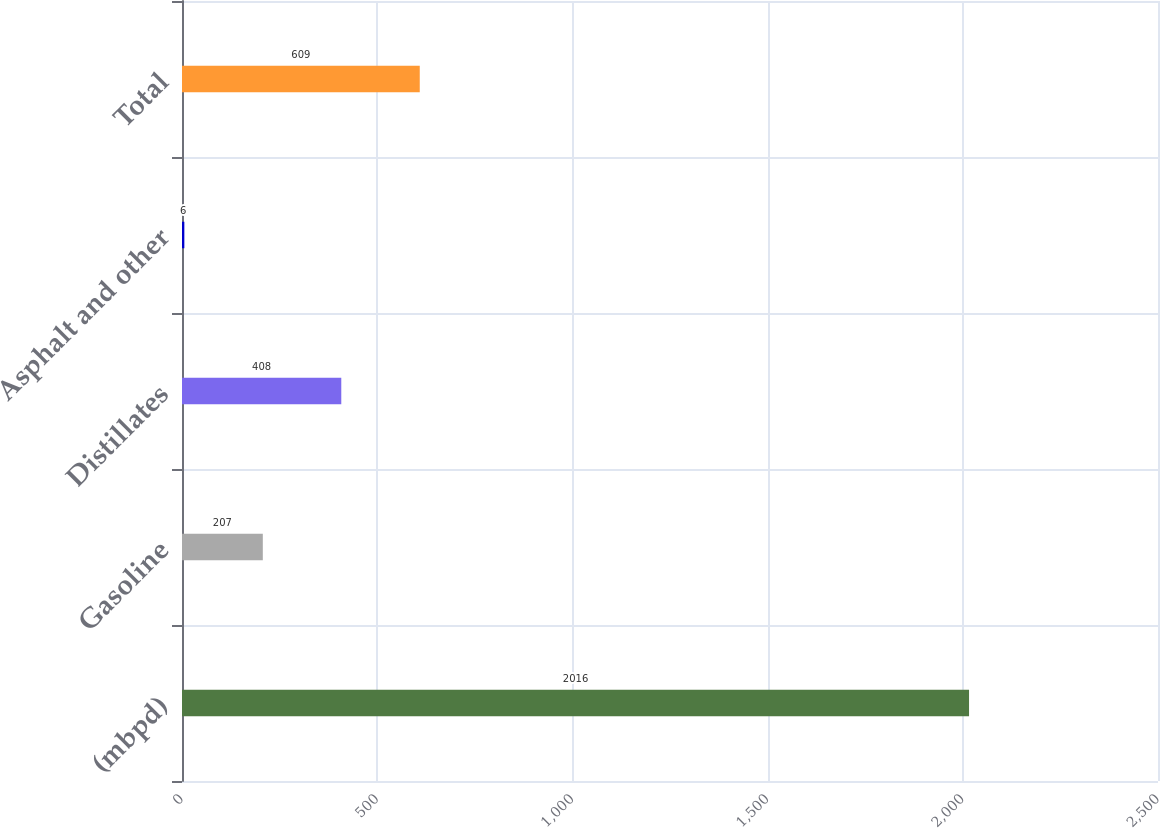<chart> <loc_0><loc_0><loc_500><loc_500><bar_chart><fcel>(mbpd)<fcel>Gasoline<fcel>Distillates<fcel>Asphalt and other<fcel>Total<nl><fcel>2016<fcel>207<fcel>408<fcel>6<fcel>609<nl></chart> 